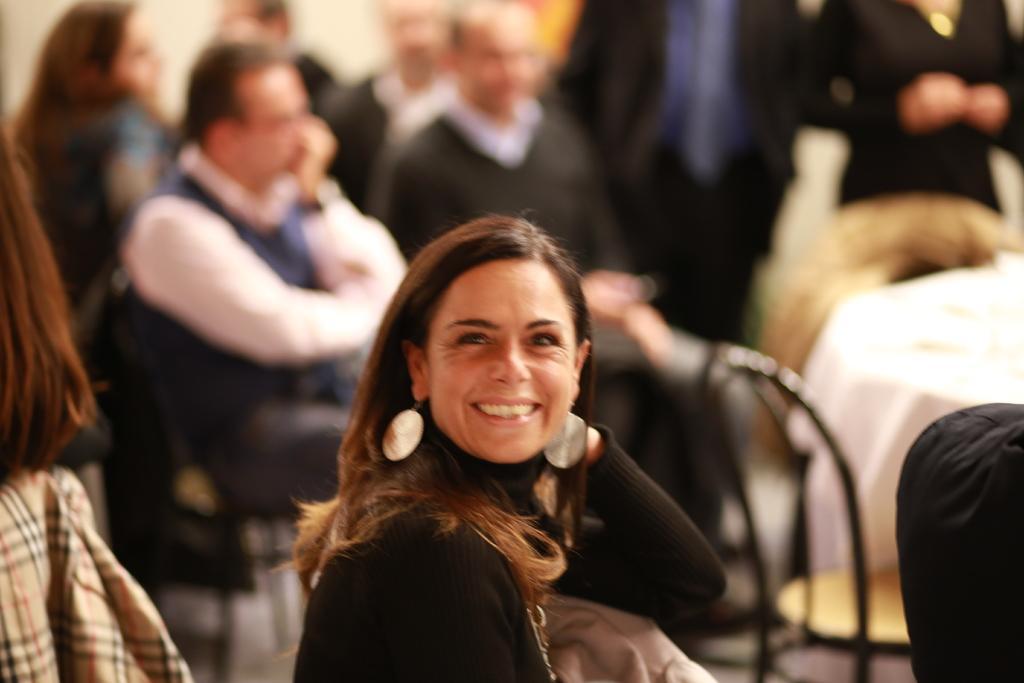Please provide a concise description of this image. In this image in the front there is a woman sitting and smiling. In the background there are persons sitting and standing, there is a table which is covered with a white colour cloth and in the front on the left side there is a person and on the right side there is an object which is black in colour. 